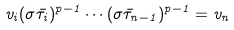Convert formula to latex. <formula><loc_0><loc_0><loc_500><loc_500>v _ { i } ( \sigma \bar { \tau } _ { i } ) ^ { p - 1 } \cdots ( \sigma \bar { \tau } _ { n - 1 } ) ^ { p - 1 } = v _ { n }</formula> 